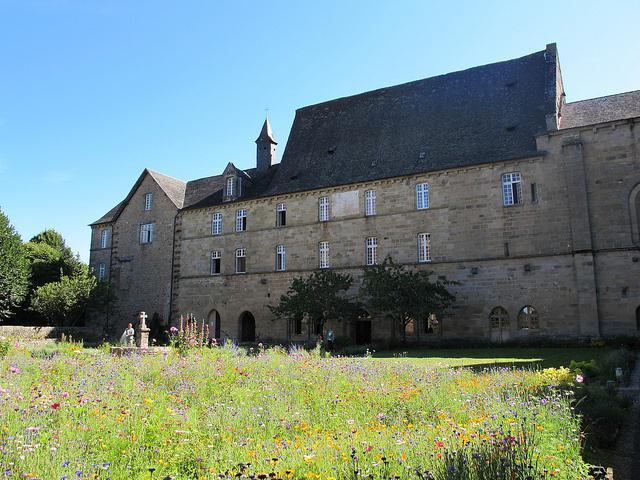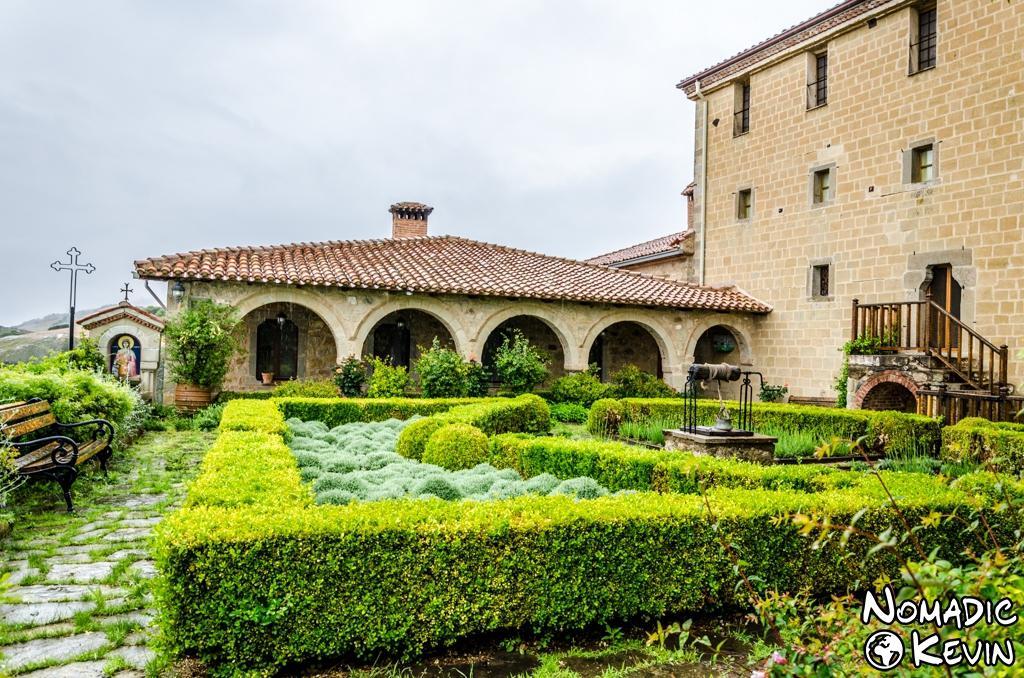The first image is the image on the left, the second image is the image on the right. For the images displayed, is the sentence "One building is beige stone with arch elements and a landscaped lawn that includes shrubs." factually correct? Answer yes or no. Yes. The first image is the image on the left, the second image is the image on the right. Analyze the images presented: Is the assertion "There's a dirt path through the grass in the left image." valid? Answer yes or no. No. 